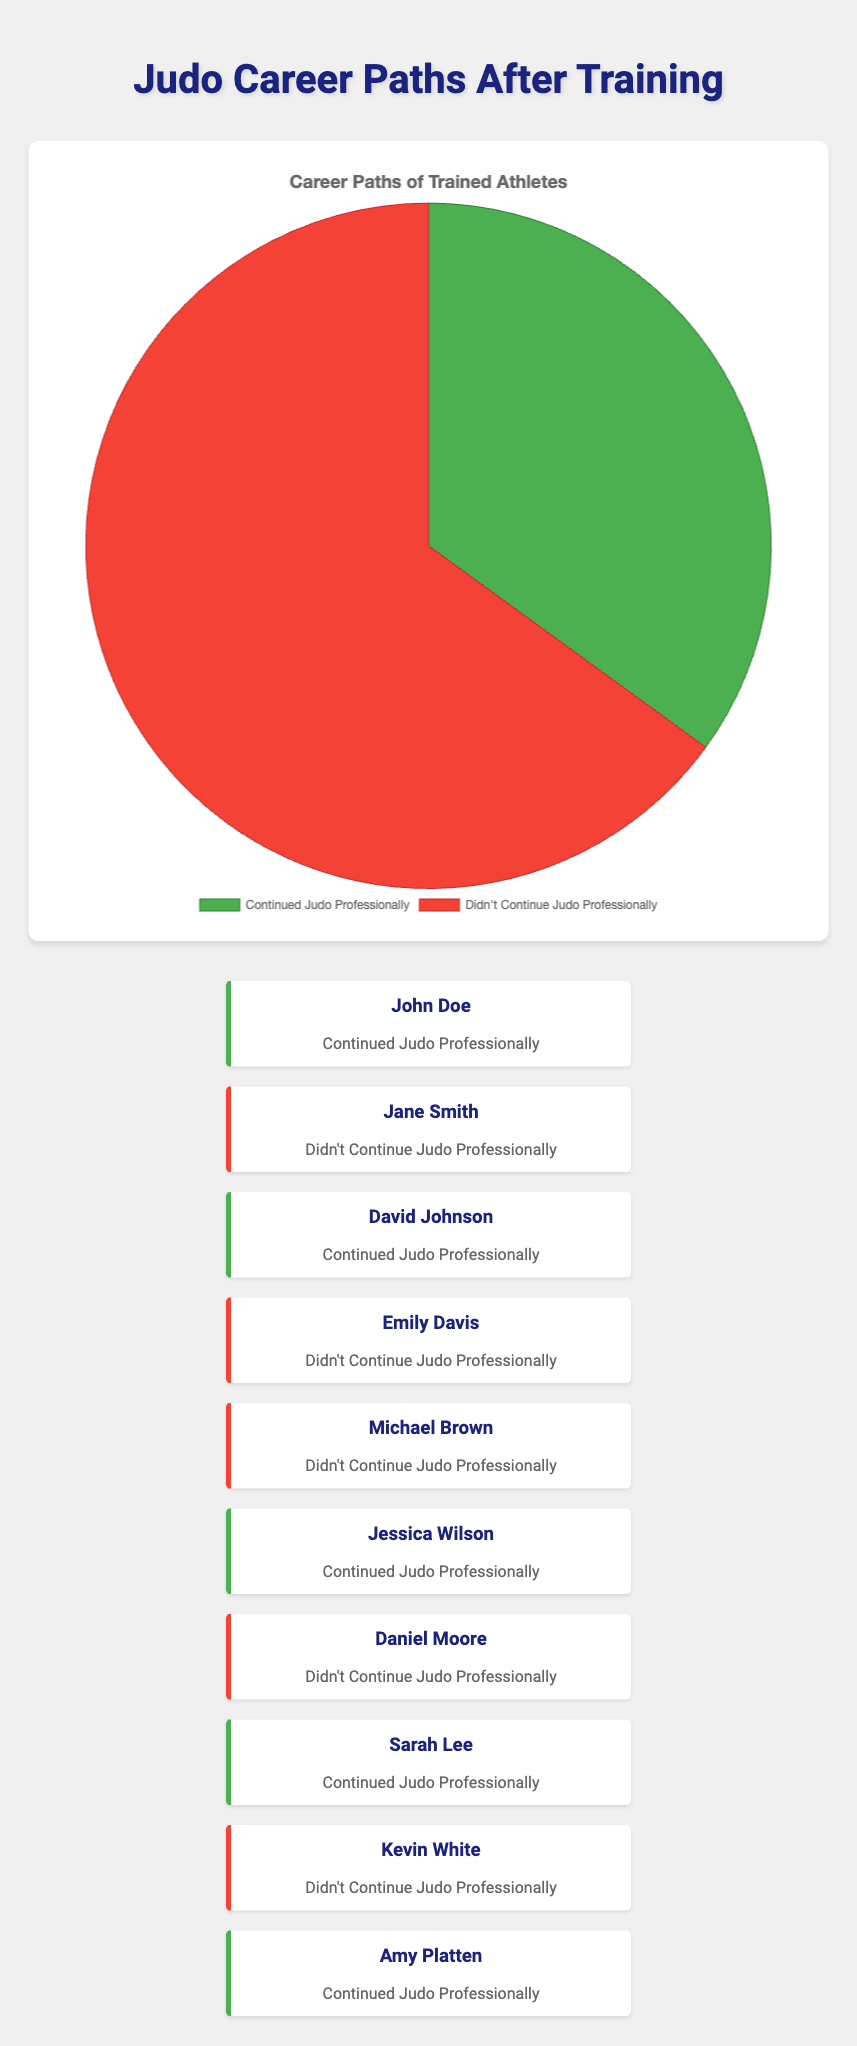Which category has the higher percentage of athletes? The chart shows two categories: "Continued Judo Professionally" and "Didn't Continue Judo Professionally." By comparing the data points, 65% didn't continue, which is higher than 35% who continued.
Answer: Didn't Continue Judo Professionally What percentage of athletes continued judo professionally? The data on the pie chart shows that 35% of the athletes continued judo professionally.
Answer: 35% What is the ratio of athletes who didn't continue judo professionally to those who did? From the data, 65% didn't continue while 35% did. The ratio is calculated as 65/35, which simplifies to 13/7.
Answer: 13:7 If there were 100 athletes, how many would have continued judo professionally? Given that 35% continued judo professionally, for 100 athletes, 0.35 * 100 = 35 athletes continued.
Answer: 35 Which slice of the pie chart is represented with the green color? The visual attribute of color green is used to indicate "Continued Judo Professionally" on the chart's legend.
Answer: Continued Judo Professionally How many more percent of athletes didn't continue judo professionally compared to those who did? The percentage of athletes who didn't continue is 65% and those who did is 35%. The difference is 65% - 35% = 30%.
Answer: 30% What percentage of athletes did not continue judo professionally? According to the pie chart, 65% of the athletes did not continue judo professionally.
Answer: 65% If we sum the percentages of athletes who continued and those who didn't, what is the total? The total percentage is 35% + 65%, which equals 100%.
Answer: 100% Is the majority of athletes in the "Continued Judo Professionally" group? The chart shows that only 35% continued, which is less than 50%, thus not the majority.
Answer: No What fraction of the total athletes are those who continued judo professionally? 35% of the athletes continued, which in fractional form is 35/100 or simplified to 7/20.
Answer: 7/20 